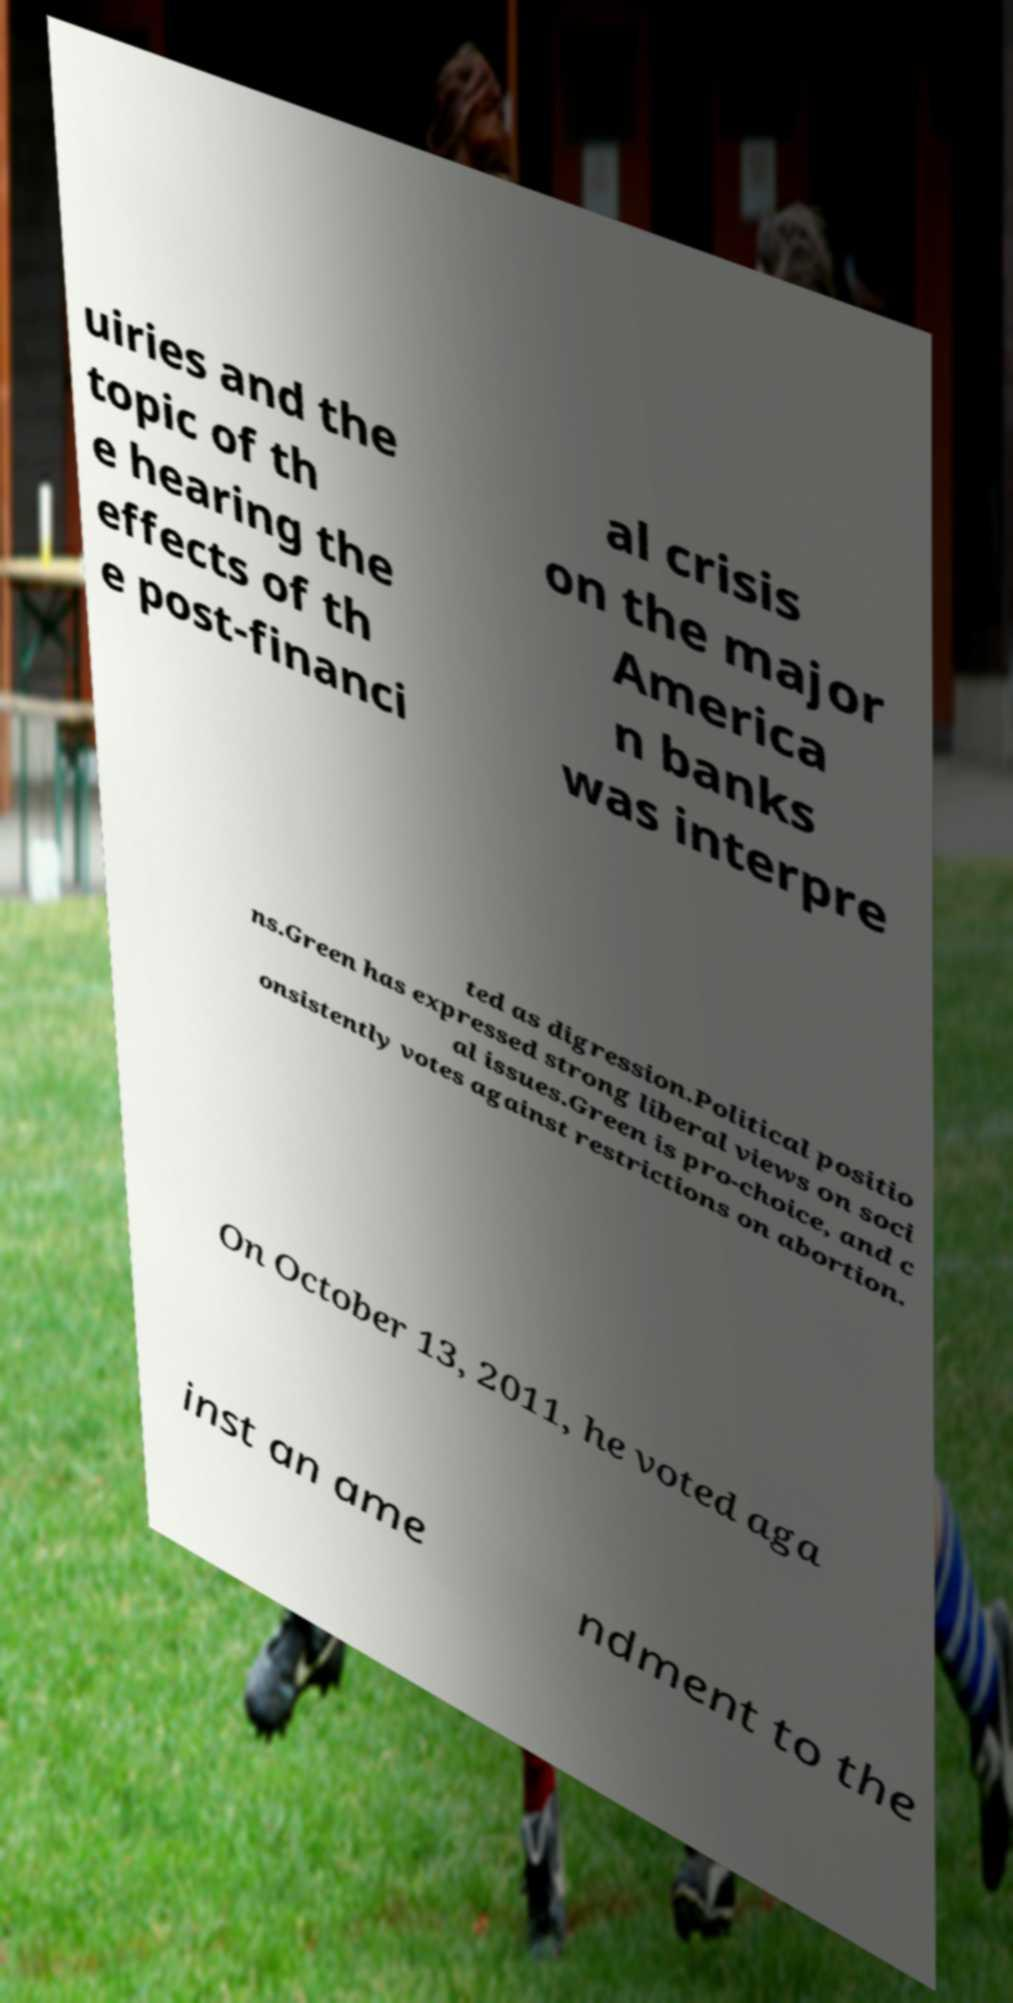I need the written content from this picture converted into text. Can you do that? uiries and the topic of th e hearing the effects of th e post-financi al crisis on the major America n banks was interpre ted as digression.Political positio ns.Green has expressed strong liberal views on soci al issues.Green is pro-choice, and c onsistently votes against restrictions on abortion. On October 13, 2011, he voted aga inst an ame ndment to the 